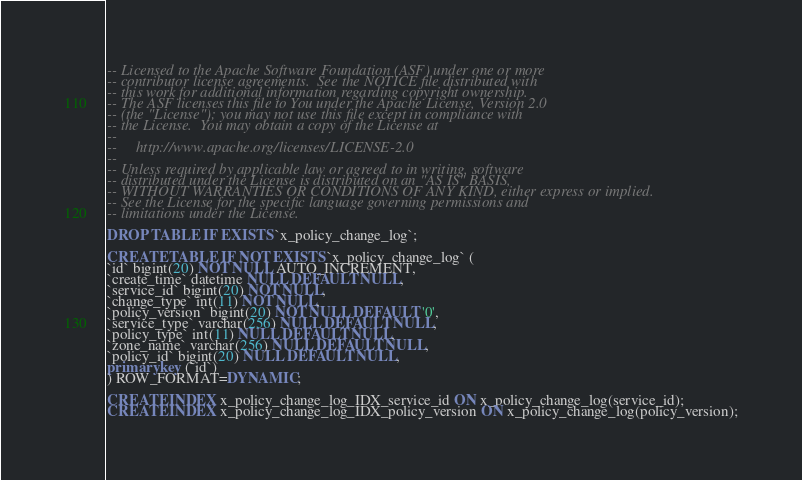Convert code to text. <code><loc_0><loc_0><loc_500><loc_500><_SQL_>-- Licensed to the Apache Software Foundation (ASF) under one or more
-- contributor license agreements.  See the NOTICE file distributed with
-- this work for additional information regarding copyright ownership.
-- The ASF licenses this file to You under the Apache License, Version 2.0
-- (the "License"); you may not use this file except in compliance with
-- the License.  You may obtain a copy of the License at
--
--     http://www.apache.org/licenses/LICENSE-2.0
--
-- Unless required by applicable law or agreed to in writing, software
-- distributed under the License is distributed on an "AS IS" BASIS,
-- WITHOUT WARRANTIES OR CONDITIONS OF ANY KIND, either express or implied.
-- See the License for the specific language governing permissions and
-- limitations under the License.

DROP TABLE IF EXISTS `x_policy_change_log`;

CREATE TABLE IF NOT EXISTS `x_policy_change_log` (
`id` bigint(20) NOT NULL AUTO_INCREMENT,
`create_time` datetime NULL DEFAULT NULL,
`service_id` bigint(20) NOT NULL,
`change_type` int(11) NOT NULL,
`policy_version` bigint(20) NOT NULL DEFAULT '0',
`service_type` varchar(256) NULL DEFAULT NULL,
`policy_type` int(11) NULL DEFAULT NULL,
`zone_name` varchar(256) NULL DEFAULT NULL,
`policy_id` bigint(20) NULL DEFAULT NULL,
primary key (`id`)
) ROW_FORMAT=DYNAMIC;

CREATE INDEX x_policy_change_log_IDX_service_id ON x_policy_change_log(service_id);
CREATE INDEX x_policy_change_log_IDX_policy_version ON x_policy_change_log(policy_version);

</code> 